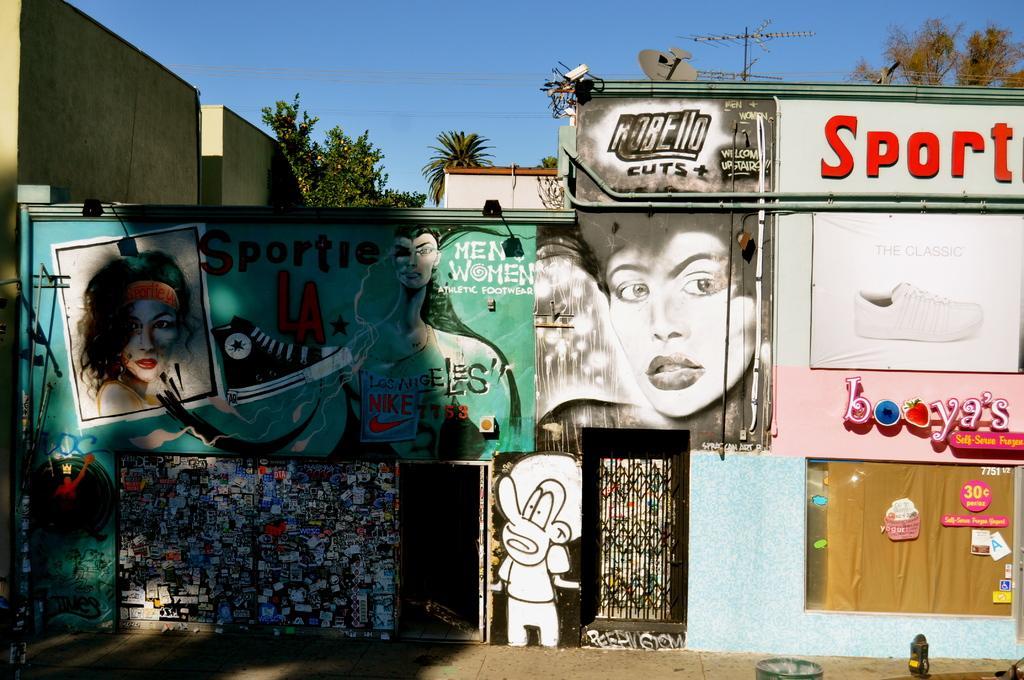Can you describe this image briefly? This image is clicked outside. This looks like graffiti. There are trees at the top. There is sky at the top. 